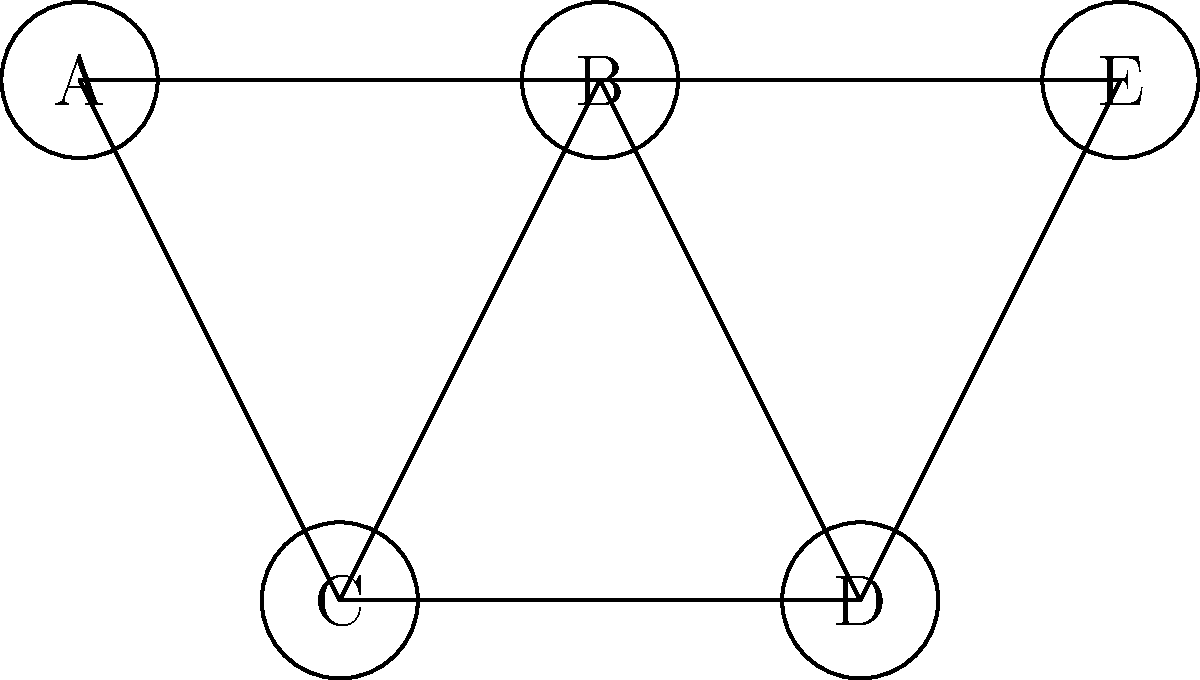In your latest retro-style game project, you're optimizing the rendering of connected game objects in a scene. The graph above represents the connections between different objects (A, B, C, D, E). To improve performance, you need to identify the largest group of mutually connected objects. What is the size of the largest clique in this graph? To find the largest clique in the graph, we'll follow these steps:

1) First, let's identify all the cliques in the graph:
   - {A, B, C}
   - {B, C, D}
   - {B, D, E}

2) A clique is a subset of vertices in which every two distinct vertices are adjacent (connected by an edge).

3) We can see that there are three cliques of size 3, and no larger cliques:
   - A, B, and C are all connected to each other
   - B, C, and D are all connected to each other
   - B, D, and E are all connected to each other

4) There are no cliques of size 4 or larger, as no group of 4 or 5 vertices are all mutually connected.

5) Therefore, the largest clique in this graph has a size of 3.

This information can be used to optimize the rendering process by grouping these mutually connected objects together, potentially reducing draw calls or enabling other optimization techniques specific to your game engine.
Answer: 3 